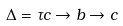Convert formula to latex. <formula><loc_0><loc_0><loc_500><loc_500>\Delta = \tau c \rightarrow b \rightarrow c</formula> 